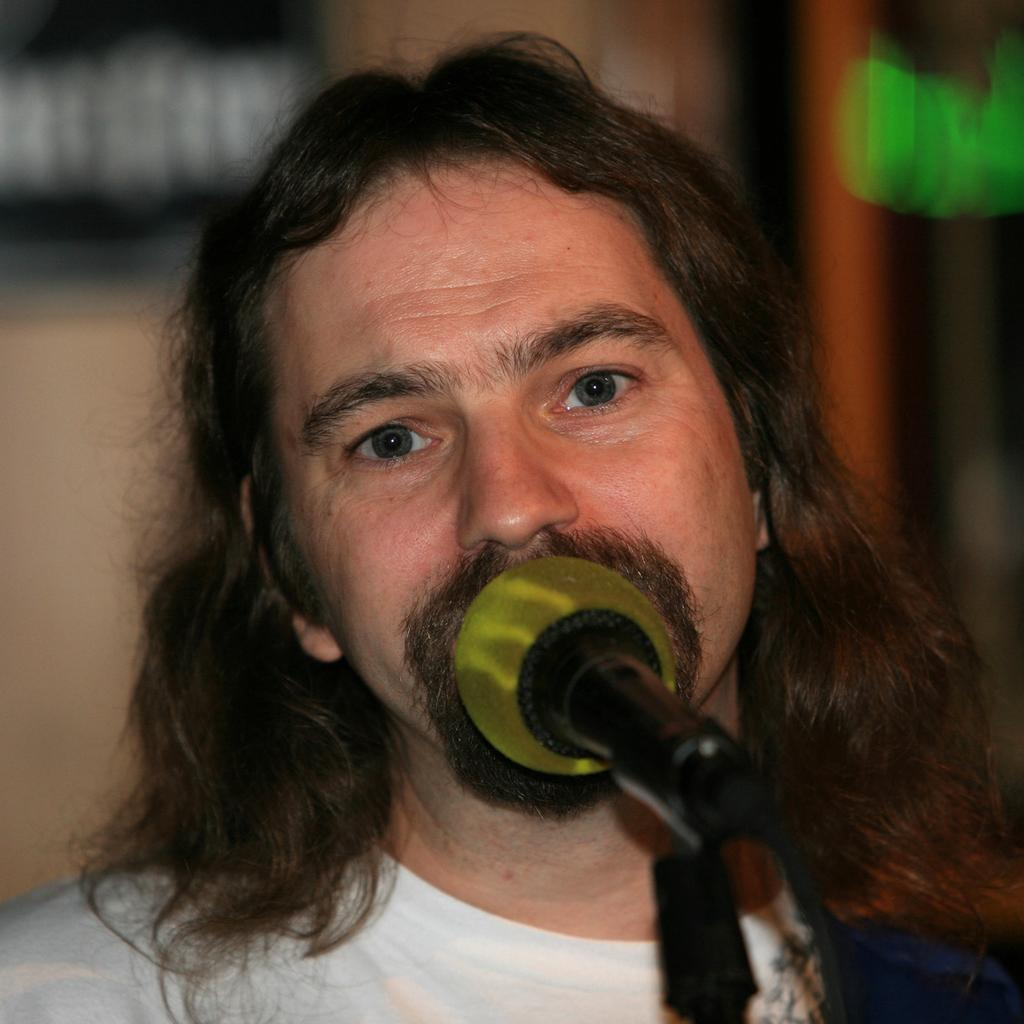Who is the main subject in the image? There is a man in the image. What object is in front of the man? There is a microphone on a stand in front of the man. What can be seen behind the man? There is a wall in the background of the image. What type of cemetery can be seen in the image? There is no cemetery present in the image. What impulse might the man be experiencing while holding the microphone? The image does not provide any information about the man's emotions or impulses, so it cannot be determined from the image. 